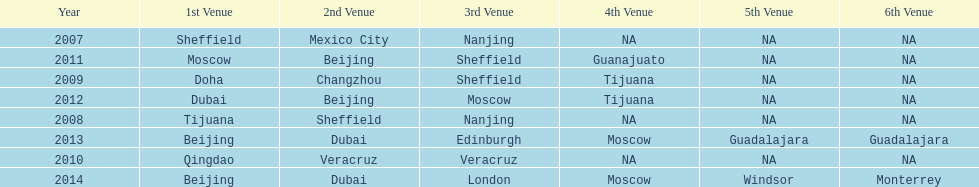Would you mind parsing the complete table? {'header': ['Year', '1st Venue', '2nd Venue', '3rd Venue', '4th Venue', '5th Venue', '6th Venue'], 'rows': [['2007', 'Sheffield', 'Mexico City', 'Nanjing', 'NA', 'NA', 'NA'], ['2011', 'Moscow', 'Beijing', 'Sheffield', 'Guanajuato', 'NA', 'NA'], ['2009', 'Doha', 'Changzhou', 'Sheffield', 'Tijuana', 'NA', 'NA'], ['2012', 'Dubai', 'Beijing', 'Moscow', 'Tijuana', 'NA', 'NA'], ['2008', 'Tijuana', 'Sheffield', 'Nanjing', 'NA', 'NA', 'NA'], ['2013', 'Beijing', 'Dubai', 'Edinburgh', 'Moscow', 'Guadalajara', 'Guadalajara'], ['2010', 'Qingdao', 'Veracruz', 'Veracruz', 'NA', 'NA', 'NA'], ['2014', 'Beijing', 'Dubai', 'London', 'Moscow', 'Windsor', 'Monterrey']]} In what year was the 3rd venue the same as 2011's 1st venue? 2012. 